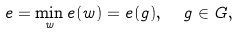Convert formula to latex. <formula><loc_0><loc_0><loc_500><loc_500>e = \min _ { w } e ( w ) = e ( g ) , \ \ g \in G ,</formula> 